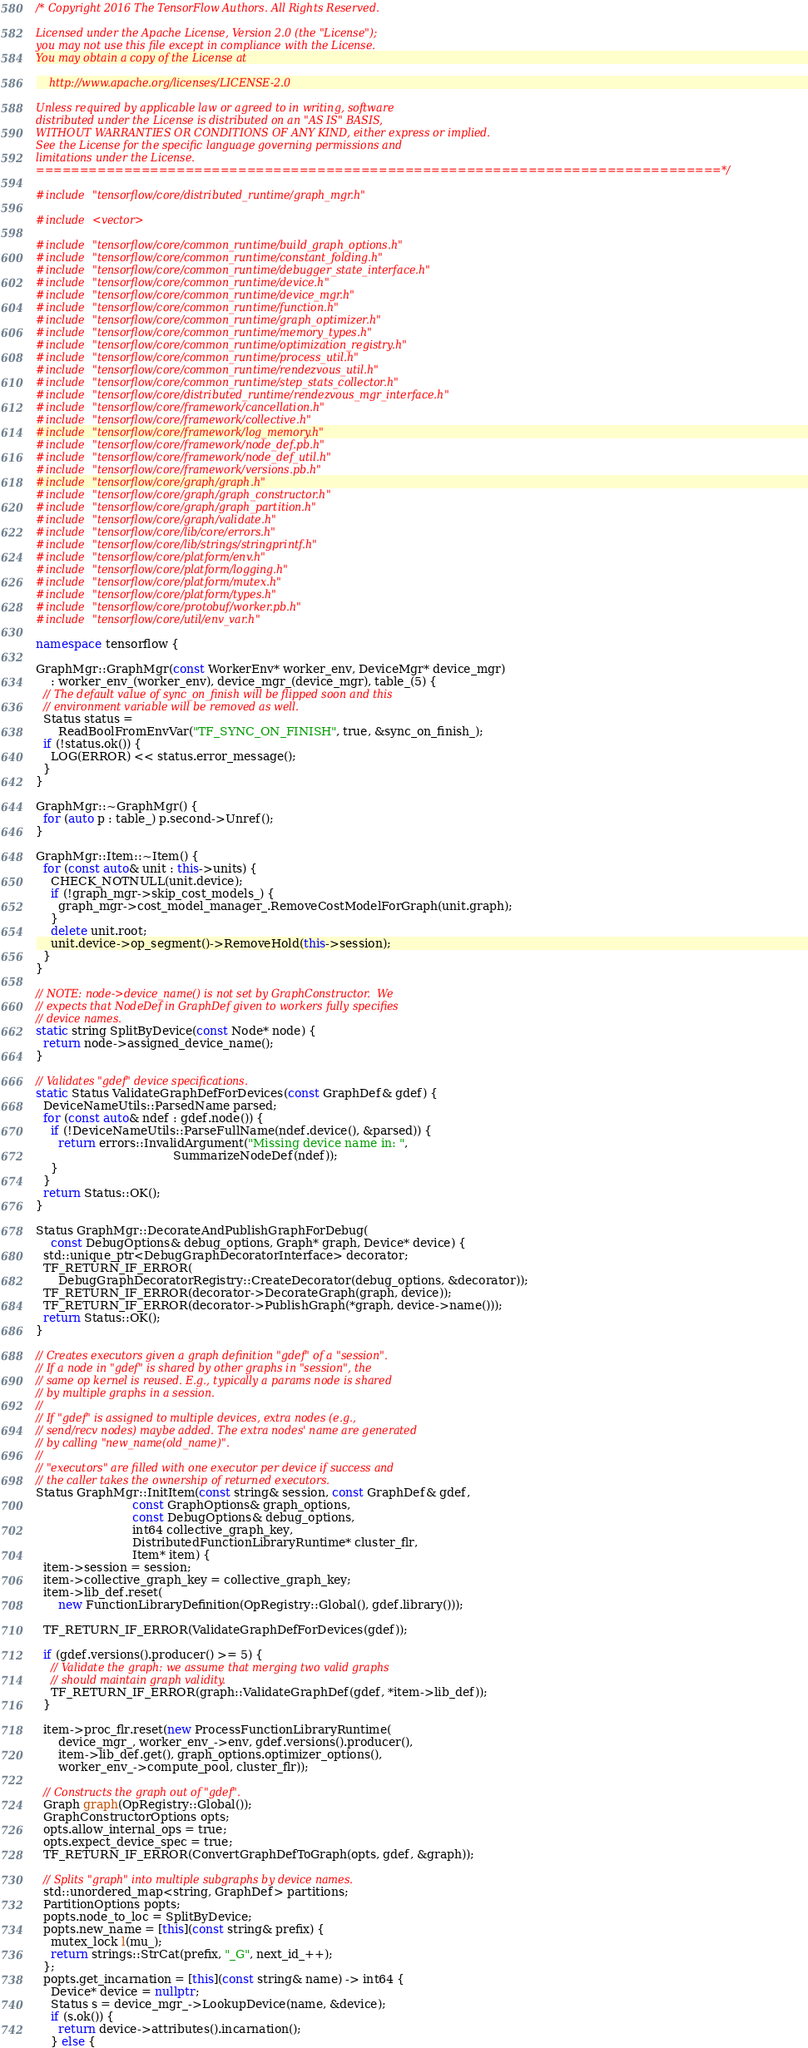Convert code to text. <code><loc_0><loc_0><loc_500><loc_500><_C++_>/* Copyright 2016 The TensorFlow Authors. All Rights Reserved.

Licensed under the Apache License, Version 2.0 (the "License");
you may not use this file except in compliance with the License.
You may obtain a copy of the License at

    http://www.apache.org/licenses/LICENSE-2.0

Unless required by applicable law or agreed to in writing, software
distributed under the License is distributed on an "AS IS" BASIS,
WITHOUT WARRANTIES OR CONDITIONS OF ANY KIND, either express or implied.
See the License for the specific language governing permissions and
limitations under the License.
==============================================================================*/

#include "tensorflow/core/distributed_runtime/graph_mgr.h"

#include <vector>

#include "tensorflow/core/common_runtime/build_graph_options.h"
#include "tensorflow/core/common_runtime/constant_folding.h"
#include "tensorflow/core/common_runtime/debugger_state_interface.h"
#include "tensorflow/core/common_runtime/device.h"
#include "tensorflow/core/common_runtime/device_mgr.h"
#include "tensorflow/core/common_runtime/function.h"
#include "tensorflow/core/common_runtime/graph_optimizer.h"
#include "tensorflow/core/common_runtime/memory_types.h"
#include "tensorflow/core/common_runtime/optimization_registry.h"
#include "tensorflow/core/common_runtime/process_util.h"
#include "tensorflow/core/common_runtime/rendezvous_util.h"
#include "tensorflow/core/common_runtime/step_stats_collector.h"
#include "tensorflow/core/distributed_runtime/rendezvous_mgr_interface.h"
#include "tensorflow/core/framework/cancellation.h"
#include "tensorflow/core/framework/collective.h"
#include "tensorflow/core/framework/log_memory.h"
#include "tensorflow/core/framework/node_def.pb.h"
#include "tensorflow/core/framework/node_def_util.h"
#include "tensorflow/core/framework/versions.pb.h"
#include "tensorflow/core/graph/graph.h"
#include "tensorflow/core/graph/graph_constructor.h"
#include "tensorflow/core/graph/graph_partition.h"
#include "tensorflow/core/graph/validate.h"
#include "tensorflow/core/lib/core/errors.h"
#include "tensorflow/core/lib/strings/stringprintf.h"
#include "tensorflow/core/platform/env.h"
#include "tensorflow/core/platform/logging.h"
#include "tensorflow/core/platform/mutex.h"
#include "tensorflow/core/platform/types.h"
#include "tensorflow/core/protobuf/worker.pb.h"
#include "tensorflow/core/util/env_var.h"

namespace tensorflow {

GraphMgr::GraphMgr(const WorkerEnv* worker_env, DeviceMgr* device_mgr)
    : worker_env_(worker_env), device_mgr_(device_mgr), table_(5) {
  // The default value of sync_on_finish will be flipped soon and this
  // environment variable will be removed as well.
  Status status =
      ReadBoolFromEnvVar("TF_SYNC_ON_FINISH", true, &sync_on_finish_);
  if (!status.ok()) {
    LOG(ERROR) << status.error_message();
  }
}

GraphMgr::~GraphMgr() {
  for (auto p : table_) p.second->Unref();
}

GraphMgr::Item::~Item() {
  for (const auto& unit : this->units) {
    CHECK_NOTNULL(unit.device);
    if (!graph_mgr->skip_cost_models_) {
      graph_mgr->cost_model_manager_.RemoveCostModelForGraph(unit.graph);
    }
    delete unit.root;
    unit.device->op_segment()->RemoveHold(this->session);
  }
}

// NOTE: node->device_name() is not set by GraphConstructor.  We
// expects that NodeDef in GraphDef given to workers fully specifies
// device names.
static string SplitByDevice(const Node* node) {
  return node->assigned_device_name();
}

// Validates "gdef" device specifications.
static Status ValidateGraphDefForDevices(const GraphDef& gdef) {
  DeviceNameUtils::ParsedName parsed;
  for (const auto& ndef : gdef.node()) {
    if (!DeviceNameUtils::ParseFullName(ndef.device(), &parsed)) {
      return errors::InvalidArgument("Missing device name in: ",
                                     SummarizeNodeDef(ndef));
    }
  }
  return Status::OK();
}

Status GraphMgr::DecorateAndPublishGraphForDebug(
    const DebugOptions& debug_options, Graph* graph, Device* device) {
  std::unique_ptr<DebugGraphDecoratorInterface> decorator;
  TF_RETURN_IF_ERROR(
      DebugGraphDecoratorRegistry::CreateDecorator(debug_options, &decorator));
  TF_RETURN_IF_ERROR(decorator->DecorateGraph(graph, device));
  TF_RETURN_IF_ERROR(decorator->PublishGraph(*graph, device->name()));
  return Status::OK();
}

// Creates executors given a graph definition "gdef" of a "session".
// If a node in "gdef" is shared by other graphs in "session", the
// same op kernel is reused. E.g., typically a params node is shared
// by multiple graphs in a session.
//
// If "gdef" is assigned to multiple devices, extra nodes (e.g.,
// send/recv nodes) maybe added. The extra nodes' name are generated
// by calling "new_name(old_name)".
//
// "executors" are filled with one executor per device if success and
// the caller takes the ownership of returned executors.
Status GraphMgr::InitItem(const string& session, const GraphDef& gdef,
                          const GraphOptions& graph_options,
                          const DebugOptions& debug_options,
                          int64 collective_graph_key,
                          DistributedFunctionLibraryRuntime* cluster_flr,
                          Item* item) {
  item->session = session;
  item->collective_graph_key = collective_graph_key;
  item->lib_def.reset(
      new FunctionLibraryDefinition(OpRegistry::Global(), gdef.library()));

  TF_RETURN_IF_ERROR(ValidateGraphDefForDevices(gdef));

  if (gdef.versions().producer() >= 5) {
    // Validate the graph: we assume that merging two valid graphs
    // should maintain graph validity.
    TF_RETURN_IF_ERROR(graph::ValidateGraphDef(gdef, *item->lib_def));
  }

  item->proc_flr.reset(new ProcessFunctionLibraryRuntime(
      device_mgr_, worker_env_->env, gdef.versions().producer(),
      item->lib_def.get(), graph_options.optimizer_options(),
      worker_env_->compute_pool, cluster_flr));

  // Constructs the graph out of "gdef".
  Graph graph(OpRegistry::Global());
  GraphConstructorOptions opts;
  opts.allow_internal_ops = true;
  opts.expect_device_spec = true;
  TF_RETURN_IF_ERROR(ConvertGraphDefToGraph(opts, gdef, &graph));

  // Splits "graph" into multiple subgraphs by device names.
  std::unordered_map<string, GraphDef> partitions;
  PartitionOptions popts;
  popts.node_to_loc = SplitByDevice;
  popts.new_name = [this](const string& prefix) {
    mutex_lock l(mu_);
    return strings::StrCat(prefix, "_G", next_id_++);
  };
  popts.get_incarnation = [this](const string& name) -> int64 {
    Device* device = nullptr;
    Status s = device_mgr_->LookupDevice(name, &device);
    if (s.ok()) {
      return device->attributes().incarnation();
    } else {</code> 